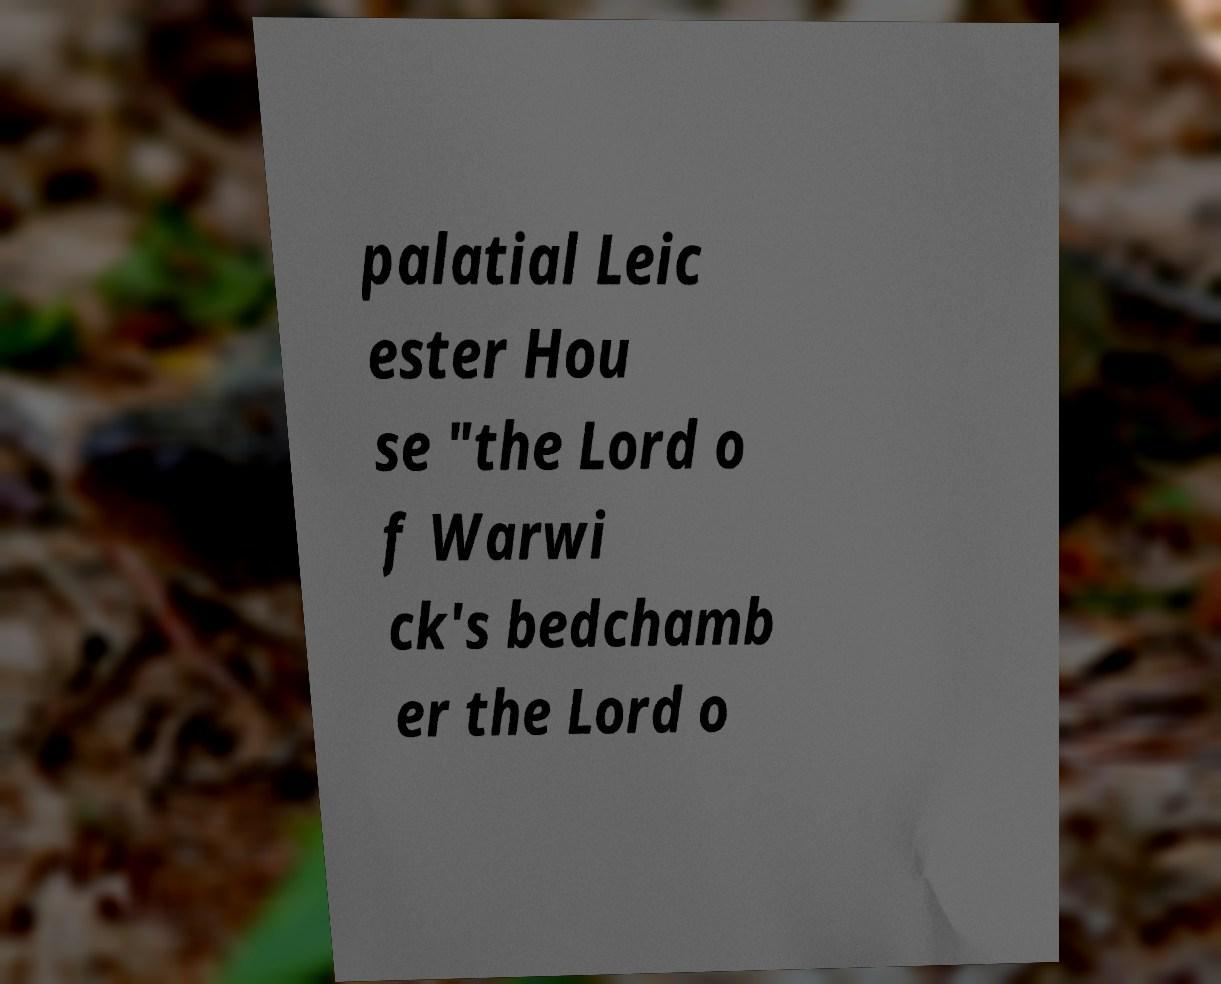There's text embedded in this image that I need extracted. Can you transcribe it verbatim? palatial Leic ester Hou se "the Lord o f Warwi ck's bedchamb er the Lord o 